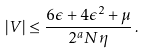Convert formula to latex. <formula><loc_0><loc_0><loc_500><loc_500>| V | \leq \frac { 6 \epsilon + 4 \epsilon ^ { 2 } + \mu } { 2 ^ { a } N \eta } \, .</formula> 